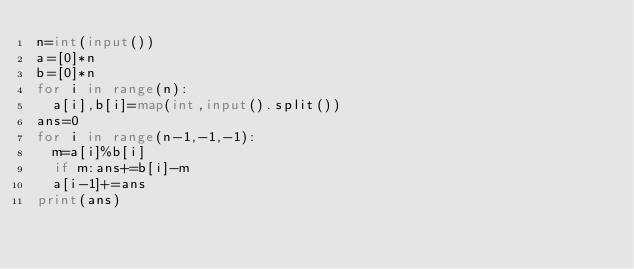Convert code to text. <code><loc_0><loc_0><loc_500><loc_500><_Python_>n=int(input())
a=[0]*n
b=[0]*n
for i in range(n):
  a[i],b[i]=map(int,input().split())
ans=0
for i in range(n-1,-1,-1):
  m=a[i]%b[i]
  if m:ans+=b[i]-m
  a[i-1]+=ans
print(ans)</code> 